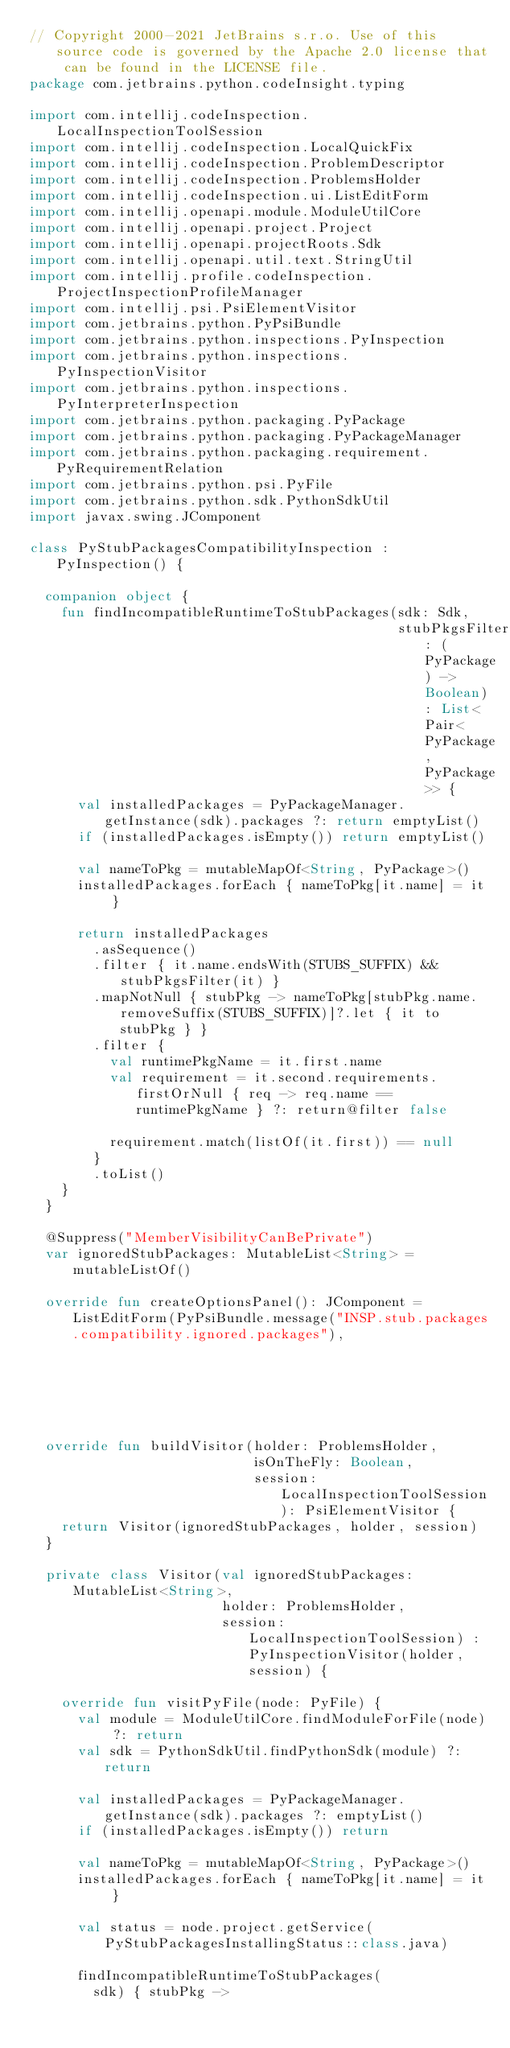Convert code to text. <code><loc_0><loc_0><loc_500><loc_500><_Kotlin_>// Copyright 2000-2021 JetBrains s.r.o. Use of this source code is governed by the Apache 2.0 license that can be found in the LICENSE file.
package com.jetbrains.python.codeInsight.typing

import com.intellij.codeInspection.LocalInspectionToolSession
import com.intellij.codeInspection.LocalQuickFix
import com.intellij.codeInspection.ProblemDescriptor
import com.intellij.codeInspection.ProblemsHolder
import com.intellij.codeInspection.ui.ListEditForm
import com.intellij.openapi.module.ModuleUtilCore
import com.intellij.openapi.project.Project
import com.intellij.openapi.projectRoots.Sdk
import com.intellij.openapi.util.text.StringUtil
import com.intellij.profile.codeInspection.ProjectInspectionProfileManager
import com.intellij.psi.PsiElementVisitor
import com.jetbrains.python.PyPsiBundle
import com.jetbrains.python.inspections.PyInspection
import com.jetbrains.python.inspections.PyInspectionVisitor
import com.jetbrains.python.inspections.PyInterpreterInspection
import com.jetbrains.python.packaging.PyPackage
import com.jetbrains.python.packaging.PyPackageManager
import com.jetbrains.python.packaging.requirement.PyRequirementRelation
import com.jetbrains.python.psi.PyFile
import com.jetbrains.python.sdk.PythonSdkUtil
import javax.swing.JComponent

class PyStubPackagesCompatibilityInspection : PyInspection() {

  companion object {
    fun findIncompatibleRuntimeToStubPackages(sdk: Sdk,
                                              stubPkgsFilter: (PyPackage) -> Boolean): List<Pair<PyPackage, PyPackage>> {
      val installedPackages = PyPackageManager.getInstance(sdk).packages ?: return emptyList()
      if (installedPackages.isEmpty()) return emptyList()

      val nameToPkg = mutableMapOf<String, PyPackage>()
      installedPackages.forEach { nameToPkg[it.name] = it }

      return installedPackages
        .asSequence()
        .filter { it.name.endsWith(STUBS_SUFFIX) && stubPkgsFilter(it) }
        .mapNotNull { stubPkg -> nameToPkg[stubPkg.name.removeSuffix(STUBS_SUFFIX)]?.let { it to stubPkg } }
        .filter {
          val runtimePkgName = it.first.name
          val requirement = it.second.requirements.firstOrNull { req -> req.name == runtimePkgName } ?: return@filter false

          requirement.match(listOf(it.first)) == null
        }
        .toList()
    }
  }

  @Suppress("MemberVisibilityCanBePrivate")
  var ignoredStubPackages: MutableList<String> = mutableListOf()

  override fun createOptionsPanel(): JComponent = ListEditForm(PyPsiBundle.message("INSP.stub.packages.compatibility.ignored.packages"),
                                                               ignoredStubPackages).contentPanel

  override fun buildVisitor(holder: ProblemsHolder,
                            isOnTheFly: Boolean,
                            session: LocalInspectionToolSession): PsiElementVisitor {
    return Visitor(ignoredStubPackages, holder, session)
  }

  private class Visitor(val ignoredStubPackages: MutableList<String>,
                        holder: ProblemsHolder,
                        session: LocalInspectionToolSession) : PyInspectionVisitor(holder, session) {

    override fun visitPyFile(node: PyFile) {
      val module = ModuleUtilCore.findModuleForFile(node) ?: return
      val sdk = PythonSdkUtil.findPythonSdk(module) ?: return

      val installedPackages = PyPackageManager.getInstance(sdk).packages ?: emptyList()
      if (installedPackages.isEmpty()) return

      val nameToPkg = mutableMapOf<String, PyPackage>()
      installedPackages.forEach { nameToPkg[it.name] = it }

      val status = node.project.getService(PyStubPackagesInstallingStatus::class.java)

      findIncompatibleRuntimeToStubPackages(
        sdk) { stubPkg -></code> 